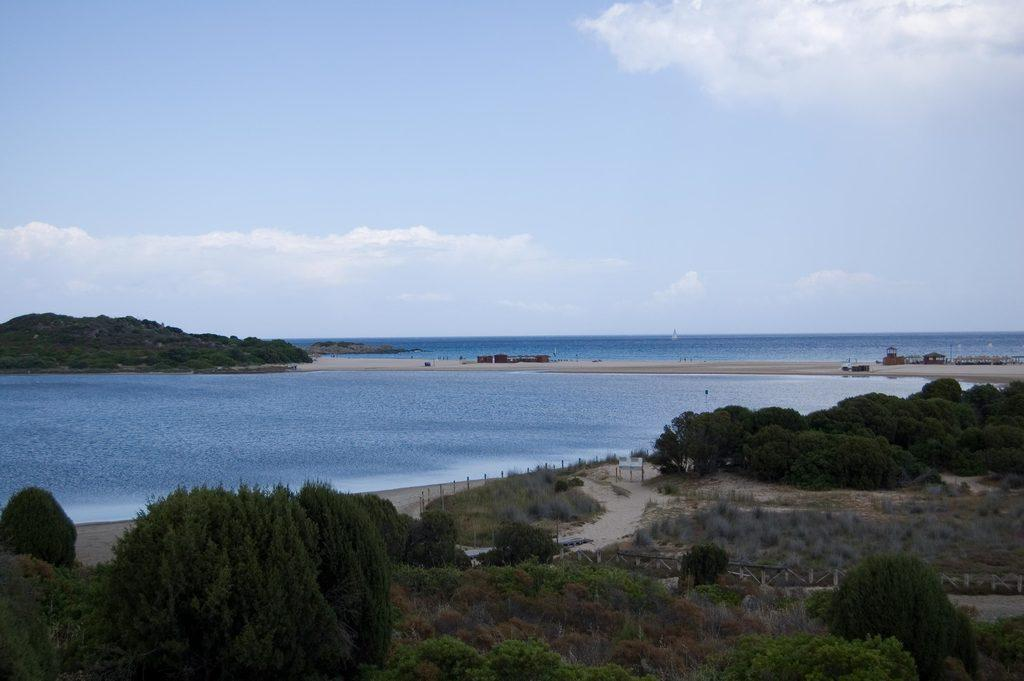What type of vegetation can be seen in the image? There are trees in the image. What structures are present in the image? There are poles and a fence in the image. What natural element is visible in the image? Water is visible in the image. What can be seen in the background of the image? The sky is visible in the background of the image, along with other objects on the ground. How does the yard increase in size in the image? There is no yard present in the image, so it cannot increase in size. What type of mark can be seen on the trees in the image? There are no marks visible on the trees in the image. 